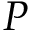Convert formula to latex. <formula><loc_0><loc_0><loc_500><loc_500>P</formula> 